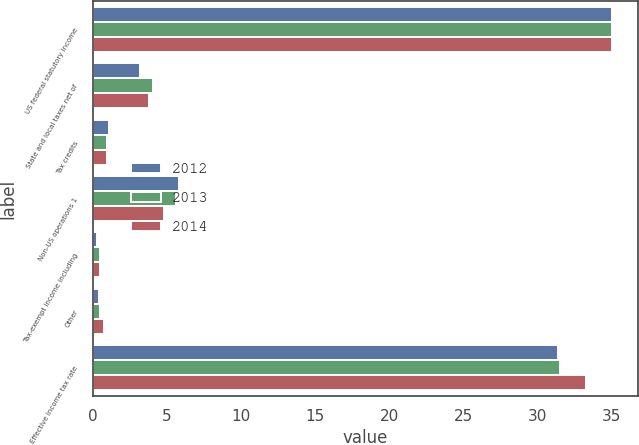<chart> <loc_0><loc_0><loc_500><loc_500><stacked_bar_chart><ecel><fcel>US federal statutory income<fcel>State and local taxes net of<fcel>Tax credits<fcel>Non-US operations 1<fcel>Tax-exempt income including<fcel>Other<fcel>Effective income tax rate<nl><fcel>2012<fcel>35<fcel>3.2<fcel>1.1<fcel>5.8<fcel>0.3<fcel>0.4<fcel>31.4<nl><fcel>2013<fcel>35<fcel>4.1<fcel>1<fcel>5.6<fcel>0.5<fcel>0.5<fcel>31.5<nl><fcel>2014<fcel>35<fcel>3.8<fcel>1<fcel>4.8<fcel>0.5<fcel>0.8<fcel>33.3<nl></chart> 